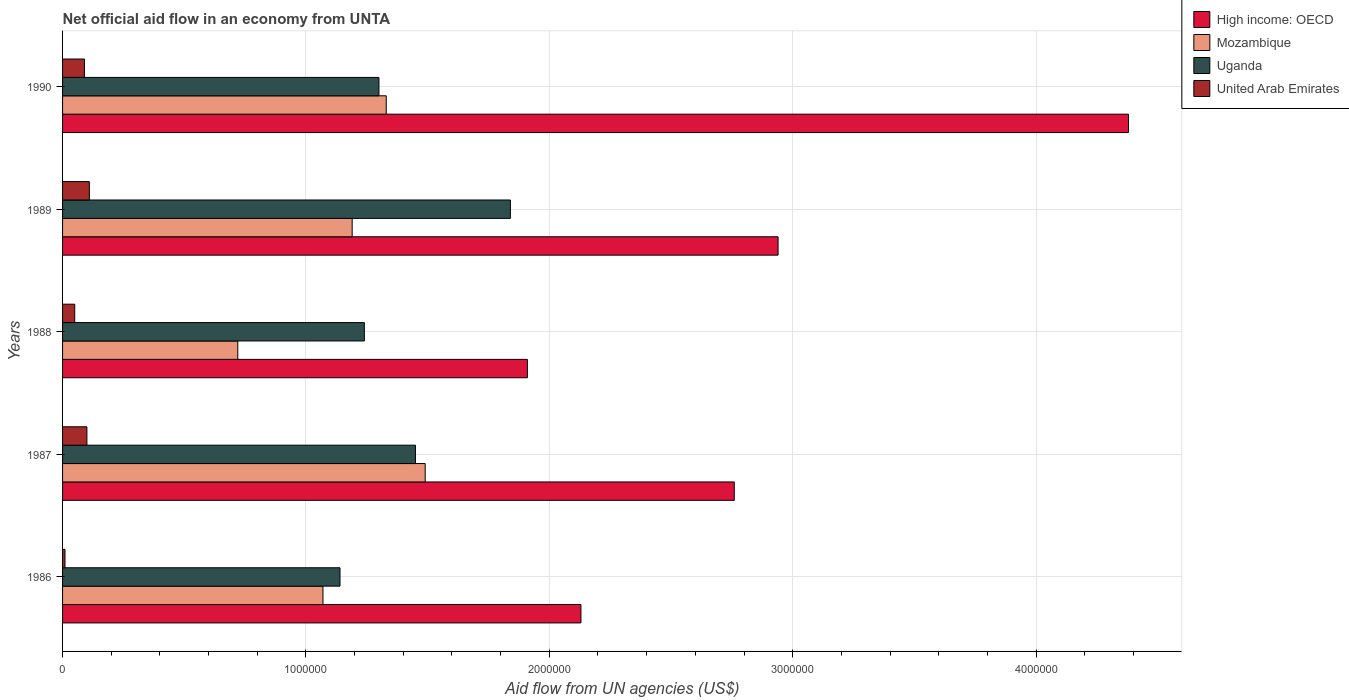Are the number of bars per tick equal to the number of legend labels?
Your answer should be compact. Yes. In how many cases, is the number of bars for a given year not equal to the number of legend labels?
Your answer should be very brief. 0. What is the net official aid flow in United Arab Emirates in 1989?
Offer a terse response. 1.10e+05. Across all years, what is the maximum net official aid flow in United Arab Emirates?
Your answer should be very brief. 1.10e+05. Across all years, what is the minimum net official aid flow in High income: OECD?
Provide a short and direct response. 1.91e+06. In which year was the net official aid flow in High income: OECD minimum?
Your response must be concise. 1988. What is the difference between the net official aid flow in United Arab Emirates in 1989 and the net official aid flow in Uganda in 1986?
Provide a succinct answer. -1.03e+06. What is the average net official aid flow in Uganda per year?
Ensure brevity in your answer.  1.39e+06. In the year 1989, what is the difference between the net official aid flow in Mozambique and net official aid flow in United Arab Emirates?
Keep it short and to the point. 1.08e+06. What is the ratio of the net official aid flow in High income: OECD in 1987 to that in 1989?
Keep it short and to the point. 0.94. Is the net official aid flow in United Arab Emirates in 1987 less than that in 1989?
Provide a succinct answer. Yes. Is the difference between the net official aid flow in Mozambique in 1986 and 1988 greater than the difference between the net official aid flow in United Arab Emirates in 1986 and 1988?
Offer a very short reply. Yes. In how many years, is the net official aid flow in High income: OECD greater than the average net official aid flow in High income: OECD taken over all years?
Keep it short and to the point. 2. What does the 4th bar from the top in 1989 represents?
Provide a succinct answer. High income: OECD. What does the 4th bar from the bottom in 1988 represents?
Provide a succinct answer. United Arab Emirates. How many bars are there?
Ensure brevity in your answer.  20. Are all the bars in the graph horizontal?
Offer a terse response. Yes. What is the difference between two consecutive major ticks on the X-axis?
Provide a short and direct response. 1.00e+06. Does the graph contain any zero values?
Make the answer very short. No. Does the graph contain grids?
Provide a succinct answer. Yes. What is the title of the graph?
Make the answer very short. Net official aid flow in an economy from UNTA. Does "Aruba" appear as one of the legend labels in the graph?
Ensure brevity in your answer.  No. What is the label or title of the X-axis?
Your answer should be compact. Aid flow from UN agencies (US$). What is the label or title of the Y-axis?
Keep it short and to the point. Years. What is the Aid flow from UN agencies (US$) in High income: OECD in 1986?
Your answer should be compact. 2.13e+06. What is the Aid flow from UN agencies (US$) of Mozambique in 1986?
Your answer should be compact. 1.07e+06. What is the Aid flow from UN agencies (US$) of Uganda in 1986?
Provide a short and direct response. 1.14e+06. What is the Aid flow from UN agencies (US$) in United Arab Emirates in 1986?
Give a very brief answer. 10000. What is the Aid flow from UN agencies (US$) in High income: OECD in 1987?
Offer a terse response. 2.76e+06. What is the Aid flow from UN agencies (US$) in Mozambique in 1987?
Keep it short and to the point. 1.49e+06. What is the Aid flow from UN agencies (US$) of Uganda in 1987?
Provide a short and direct response. 1.45e+06. What is the Aid flow from UN agencies (US$) of High income: OECD in 1988?
Offer a very short reply. 1.91e+06. What is the Aid flow from UN agencies (US$) in Mozambique in 1988?
Provide a succinct answer. 7.20e+05. What is the Aid flow from UN agencies (US$) in Uganda in 1988?
Give a very brief answer. 1.24e+06. What is the Aid flow from UN agencies (US$) of High income: OECD in 1989?
Provide a succinct answer. 2.94e+06. What is the Aid flow from UN agencies (US$) of Mozambique in 1989?
Make the answer very short. 1.19e+06. What is the Aid flow from UN agencies (US$) of Uganda in 1989?
Ensure brevity in your answer.  1.84e+06. What is the Aid flow from UN agencies (US$) in United Arab Emirates in 1989?
Your answer should be very brief. 1.10e+05. What is the Aid flow from UN agencies (US$) of High income: OECD in 1990?
Ensure brevity in your answer.  4.38e+06. What is the Aid flow from UN agencies (US$) of Mozambique in 1990?
Give a very brief answer. 1.33e+06. What is the Aid flow from UN agencies (US$) in Uganda in 1990?
Your answer should be compact. 1.30e+06. What is the Aid flow from UN agencies (US$) of United Arab Emirates in 1990?
Provide a succinct answer. 9.00e+04. Across all years, what is the maximum Aid flow from UN agencies (US$) in High income: OECD?
Offer a terse response. 4.38e+06. Across all years, what is the maximum Aid flow from UN agencies (US$) of Mozambique?
Your answer should be compact. 1.49e+06. Across all years, what is the maximum Aid flow from UN agencies (US$) in Uganda?
Offer a very short reply. 1.84e+06. Across all years, what is the maximum Aid flow from UN agencies (US$) of United Arab Emirates?
Your response must be concise. 1.10e+05. Across all years, what is the minimum Aid flow from UN agencies (US$) of High income: OECD?
Provide a short and direct response. 1.91e+06. Across all years, what is the minimum Aid flow from UN agencies (US$) of Mozambique?
Provide a succinct answer. 7.20e+05. Across all years, what is the minimum Aid flow from UN agencies (US$) of Uganda?
Ensure brevity in your answer.  1.14e+06. What is the total Aid flow from UN agencies (US$) in High income: OECD in the graph?
Offer a terse response. 1.41e+07. What is the total Aid flow from UN agencies (US$) of Mozambique in the graph?
Ensure brevity in your answer.  5.80e+06. What is the total Aid flow from UN agencies (US$) in Uganda in the graph?
Keep it short and to the point. 6.97e+06. What is the total Aid flow from UN agencies (US$) of United Arab Emirates in the graph?
Ensure brevity in your answer.  3.60e+05. What is the difference between the Aid flow from UN agencies (US$) in High income: OECD in 1986 and that in 1987?
Give a very brief answer. -6.30e+05. What is the difference between the Aid flow from UN agencies (US$) of Mozambique in 1986 and that in 1987?
Make the answer very short. -4.20e+05. What is the difference between the Aid flow from UN agencies (US$) in Uganda in 1986 and that in 1987?
Offer a terse response. -3.10e+05. What is the difference between the Aid flow from UN agencies (US$) of High income: OECD in 1986 and that in 1988?
Make the answer very short. 2.20e+05. What is the difference between the Aid flow from UN agencies (US$) of Mozambique in 1986 and that in 1988?
Your answer should be compact. 3.50e+05. What is the difference between the Aid flow from UN agencies (US$) in United Arab Emirates in 1986 and that in 1988?
Keep it short and to the point. -4.00e+04. What is the difference between the Aid flow from UN agencies (US$) in High income: OECD in 1986 and that in 1989?
Your response must be concise. -8.10e+05. What is the difference between the Aid flow from UN agencies (US$) in Mozambique in 1986 and that in 1989?
Your response must be concise. -1.20e+05. What is the difference between the Aid flow from UN agencies (US$) in Uganda in 1986 and that in 1989?
Your response must be concise. -7.00e+05. What is the difference between the Aid flow from UN agencies (US$) in High income: OECD in 1986 and that in 1990?
Give a very brief answer. -2.25e+06. What is the difference between the Aid flow from UN agencies (US$) in Mozambique in 1986 and that in 1990?
Provide a succinct answer. -2.60e+05. What is the difference between the Aid flow from UN agencies (US$) in United Arab Emirates in 1986 and that in 1990?
Your answer should be compact. -8.00e+04. What is the difference between the Aid flow from UN agencies (US$) in High income: OECD in 1987 and that in 1988?
Your response must be concise. 8.50e+05. What is the difference between the Aid flow from UN agencies (US$) in Mozambique in 1987 and that in 1988?
Provide a succinct answer. 7.70e+05. What is the difference between the Aid flow from UN agencies (US$) of Uganda in 1987 and that in 1988?
Provide a succinct answer. 2.10e+05. What is the difference between the Aid flow from UN agencies (US$) in United Arab Emirates in 1987 and that in 1988?
Provide a succinct answer. 5.00e+04. What is the difference between the Aid flow from UN agencies (US$) of Uganda in 1987 and that in 1989?
Give a very brief answer. -3.90e+05. What is the difference between the Aid flow from UN agencies (US$) in High income: OECD in 1987 and that in 1990?
Keep it short and to the point. -1.62e+06. What is the difference between the Aid flow from UN agencies (US$) in Mozambique in 1987 and that in 1990?
Your answer should be compact. 1.60e+05. What is the difference between the Aid flow from UN agencies (US$) in High income: OECD in 1988 and that in 1989?
Your response must be concise. -1.03e+06. What is the difference between the Aid flow from UN agencies (US$) of Mozambique in 1988 and that in 1989?
Offer a terse response. -4.70e+05. What is the difference between the Aid flow from UN agencies (US$) in Uganda in 1988 and that in 1989?
Your response must be concise. -6.00e+05. What is the difference between the Aid flow from UN agencies (US$) of United Arab Emirates in 1988 and that in 1989?
Ensure brevity in your answer.  -6.00e+04. What is the difference between the Aid flow from UN agencies (US$) of High income: OECD in 1988 and that in 1990?
Offer a terse response. -2.47e+06. What is the difference between the Aid flow from UN agencies (US$) in Mozambique in 1988 and that in 1990?
Your answer should be very brief. -6.10e+05. What is the difference between the Aid flow from UN agencies (US$) of Uganda in 1988 and that in 1990?
Provide a succinct answer. -6.00e+04. What is the difference between the Aid flow from UN agencies (US$) in United Arab Emirates in 1988 and that in 1990?
Your answer should be very brief. -4.00e+04. What is the difference between the Aid flow from UN agencies (US$) of High income: OECD in 1989 and that in 1990?
Offer a very short reply. -1.44e+06. What is the difference between the Aid flow from UN agencies (US$) in Mozambique in 1989 and that in 1990?
Give a very brief answer. -1.40e+05. What is the difference between the Aid flow from UN agencies (US$) of Uganda in 1989 and that in 1990?
Provide a succinct answer. 5.40e+05. What is the difference between the Aid flow from UN agencies (US$) of United Arab Emirates in 1989 and that in 1990?
Make the answer very short. 2.00e+04. What is the difference between the Aid flow from UN agencies (US$) of High income: OECD in 1986 and the Aid flow from UN agencies (US$) of Mozambique in 1987?
Your answer should be very brief. 6.40e+05. What is the difference between the Aid flow from UN agencies (US$) in High income: OECD in 1986 and the Aid flow from UN agencies (US$) in Uganda in 1987?
Provide a short and direct response. 6.80e+05. What is the difference between the Aid flow from UN agencies (US$) of High income: OECD in 1986 and the Aid flow from UN agencies (US$) of United Arab Emirates in 1987?
Offer a terse response. 2.03e+06. What is the difference between the Aid flow from UN agencies (US$) of Mozambique in 1986 and the Aid flow from UN agencies (US$) of Uganda in 1987?
Ensure brevity in your answer.  -3.80e+05. What is the difference between the Aid flow from UN agencies (US$) in Mozambique in 1986 and the Aid flow from UN agencies (US$) in United Arab Emirates in 1987?
Provide a succinct answer. 9.70e+05. What is the difference between the Aid flow from UN agencies (US$) in Uganda in 1986 and the Aid flow from UN agencies (US$) in United Arab Emirates in 1987?
Make the answer very short. 1.04e+06. What is the difference between the Aid flow from UN agencies (US$) in High income: OECD in 1986 and the Aid flow from UN agencies (US$) in Mozambique in 1988?
Make the answer very short. 1.41e+06. What is the difference between the Aid flow from UN agencies (US$) in High income: OECD in 1986 and the Aid flow from UN agencies (US$) in Uganda in 1988?
Provide a succinct answer. 8.90e+05. What is the difference between the Aid flow from UN agencies (US$) of High income: OECD in 1986 and the Aid flow from UN agencies (US$) of United Arab Emirates in 1988?
Give a very brief answer. 2.08e+06. What is the difference between the Aid flow from UN agencies (US$) in Mozambique in 1986 and the Aid flow from UN agencies (US$) in Uganda in 1988?
Your answer should be compact. -1.70e+05. What is the difference between the Aid flow from UN agencies (US$) of Mozambique in 1986 and the Aid flow from UN agencies (US$) of United Arab Emirates in 1988?
Ensure brevity in your answer.  1.02e+06. What is the difference between the Aid flow from UN agencies (US$) of Uganda in 1986 and the Aid flow from UN agencies (US$) of United Arab Emirates in 1988?
Ensure brevity in your answer.  1.09e+06. What is the difference between the Aid flow from UN agencies (US$) of High income: OECD in 1986 and the Aid flow from UN agencies (US$) of Mozambique in 1989?
Your answer should be compact. 9.40e+05. What is the difference between the Aid flow from UN agencies (US$) of High income: OECD in 1986 and the Aid flow from UN agencies (US$) of United Arab Emirates in 1989?
Offer a very short reply. 2.02e+06. What is the difference between the Aid flow from UN agencies (US$) of Mozambique in 1986 and the Aid flow from UN agencies (US$) of Uganda in 1989?
Offer a terse response. -7.70e+05. What is the difference between the Aid flow from UN agencies (US$) of Mozambique in 1986 and the Aid flow from UN agencies (US$) of United Arab Emirates in 1989?
Keep it short and to the point. 9.60e+05. What is the difference between the Aid flow from UN agencies (US$) of Uganda in 1986 and the Aid flow from UN agencies (US$) of United Arab Emirates in 1989?
Give a very brief answer. 1.03e+06. What is the difference between the Aid flow from UN agencies (US$) in High income: OECD in 1986 and the Aid flow from UN agencies (US$) in Uganda in 1990?
Offer a terse response. 8.30e+05. What is the difference between the Aid flow from UN agencies (US$) in High income: OECD in 1986 and the Aid flow from UN agencies (US$) in United Arab Emirates in 1990?
Make the answer very short. 2.04e+06. What is the difference between the Aid flow from UN agencies (US$) of Mozambique in 1986 and the Aid flow from UN agencies (US$) of Uganda in 1990?
Keep it short and to the point. -2.30e+05. What is the difference between the Aid flow from UN agencies (US$) of Mozambique in 1986 and the Aid flow from UN agencies (US$) of United Arab Emirates in 1990?
Offer a terse response. 9.80e+05. What is the difference between the Aid flow from UN agencies (US$) in Uganda in 1986 and the Aid flow from UN agencies (US$) in United Arab Emirates in 1990?
Provide a short and direct response. 1.05e+06. What is the difference between the Aid flow from UN agencies (US$) in High income: OECD in 1987 and the Aid flow from UN agencies (US$) in Mozambique in 1988?
Give a very brief answer. 2.04e+06. What is the difference between the Aid flow from UN agencies (US$) of High income: OECD in 1987 and the Aid flow from UN agencies (US$) of Uganda in 1988?
Give a very brief answer. 1.52e+06. What is the difference between the Aid flow from UN agencies (US$) of High income: OECD in 1987 and the Aid flow from UN agencies (US$) of United Arab Emirates in 1988?
Provide a succinct answer. 2.71e+06. What is the difference between the Aid flow from UN agencies (US$) in Mozambique in 1987 and the Aid flow from UN agencies (US$) in Uganda in 1988?
Make the answer very short. 2.50e+05. What is the difference between the Aid flow from UN agencies (US$) in Mozambique in 1987 and the Aid flow from UN agencies (US$) in United Arab Emirates in 1988?
Your answer should be compact. 1.44e+06. What is the difference between the Aid flow from UN agencies (US$) in Uganda in 1987 and the Aid flow from UN agencies (US$) in United Arab Emirates in 1988?
Provide a short and direct response. 1.40e+06. What is the difference between the Aid flow from UN agencies (US$) in High income: OECD in 1987 and the Aid flow from UN agencies (US$) in Mozambique in 1989?
Your answer should be compact. 1.57e+06. What is the difference between the Aid flow from UN agencies (US$) of High income: OECD in 1987 and the Aid flow from UN agencies (US$) of Uganda in 1989?
Keep it short and to the point. 9.20e+05. What is the difference between the Aid flow from UN agencies (US$) in High income: OECD in 1987 and the Aid flow from UN agencies (US$) in United Arab Emirates in 1989?
Offer a very short reply. 2.65e+06. What is the difference between the Aid flow from UN agencies (US$) in Mozambique in 1987 and the Aid flow from UN agencies (US$) in Uganda in 1989?
Your response must be concise. -3.50e+05. What is the difference between the Aid flow from UN agencies (US$) of Mozambique in 1987 and the Aid flow from UN agencies (US$) of United Arab Emirates in 1989?
Keep it short and to the point. 1.38e+06. What is the difference between the Aid flow from UN agencies (US$) of Uganda in 1987 and the Aid flow from UN agencies (US$) of United Arab Emirates in 1989?
Your answer should be compact. 1.34e+06. What is the difference between the Aid flow from UN agencies (US$) of High income: OECD in 1987 and the Aid flow from UN agencies (US$) of Mozambique in 1990?
Give a very brief answer. 1.43e+06. What is the difference between the Aid flow from UN agencies (US$) in High income: OECD in 1987 and the Aid flow from UN agencies (US$) in Uganda in 1990?
Provide a short and direct response. 1.46e+06. What is the difference between the Aid flow from UN agencies (US$) in High income: OECD in 1987 and the Aid flow from UN agencies (US$) in United Arab Emirates in 1990?
Make the answer very short. 2.67e+06. What is the difference between the Aid flow from UN agencies (US$) in Mozambique in 1987 and the Aid flow from UN agencies (US$) in Uganda in 1990?
Offer a terse response. 1.90e+05. What is the difference between the Aid flow from UN agencies (US$) of Mozambique in 1987 and the Aid flow from UN agencies (US$) of United Arab Emirates in 1990?
Provide a succinct answer. 1.40e+06. What is the difference between the Aid flow from UN agencies (US$) of Uganda in 1987 and the Aid flow from UN agencies (US$) of United Arab Emirates in 1990?
Your response must be concise. 1.36e+06. What is the difference between the Aid flow from UN agencies (US$) of High income: OECD in 1988 and the Aid flow from UN agencies (US$) of Mozambique in 1989?
Provide a short and direct response. 7.20e+05. What is the difference between the Aid flow from UN agencies (US$) of High income: OECD in 1988 and the Aid flow from UN agencies (US$) of United Arab Emirates in 1989?
Offer a very short reply. 1.80e+06. What is the difference between the Aid flow from UN agencies (US$) of Mozambique in 1988 and the Aid flow from UN agencies (US$) of Uganda in 1989?
Provide a short and direct response. -1.12e+06. What is the difference between the Aid flow from UN agencies (US$) in Uganda in 1988 and the Aid flow from UN agencies (US$) in United Arab Emirates in 1989?
Give a very brief answer. 1.13e+06. What is the difference between the Aid flow from UN agencies (US$) of High income: OECD in 1988 and the Aid flow from UN agencies (US$) of Mozambique in 1990?
Your response must be concise. 5.80e+05. What is the difference between the Aid flow from UN agencies (US$) of High income: OECD in 1988 and the Aid flow from UN agencies (US$) of United Arab Emirates in 1990?
Provide a succinct answer. 1.82e+06. What is the difference between the Aid flow from UN agencies (US$) in Mozambique in 1988 and the Aid flow from UN agencies (US$) in Uganda in 1990?
Give a very brief answer. -5.80e+05. What is the difference between the Aid flow from UN agencies (US$) in Mozambique in 1988 and the Aid flow from UN agencies (US$) in United Arab Emirates in 1990?
Keep it short and to the point. 6.30e+05. What is the difference between the Aid flow from UN agencies (US$) of Uganda in 1988 and the Aid flow from UN agencies (US$) of United Arab Emirates in 1990?
Your response must be concise. 1.15e+06. What is the difference between the Aid flow from UN agencies (US$) in High income: OECD in 1989 and the Aid flow from UN agencies (US$) in Mozambique in 1990?
Your answer should be very brief. 1.61e+06. What is the difference between the Aid flow from UN agencies (US$) in High income: OECD in 1989 and the Aid flow from UN agencies (US$) in Uganda in 1990?
Offer a terse response. 1.64e+06. What is the difference between the Aid flow from UN agencies (US$) of High income: OECD in 1989 and the Aid flow from UN agencies (US$) of United Arab Emirates in 1990?
Offer a terse response. 2.85e+06. What is the difference between the Aid flow from UN agencies (US$) in Mozambique in 1989 and the Aid flow from UN agencies (US$) in Uganda in 1990?
Provide a short and direct response. -1.10e+05. What is the difference between the Aid flow from UN agencies (US$) of Mozambique in 1989 and the Aid flow from UN agencies (US$) of United Arab Emirates in 1990?
Your answer should be compact. 1.10e+06. What is the difference between the Aid flow from UN agencies (US$) in Uganda in 1989 and the Aid flow from UN agencies (US$) in United Arab Emirates in 1990?
Offer a very short reply. 1.75e+06. What is the average Aid flow from UN agencies (US$) of High income: OECD per year?
Your answer should be very brief. 2.82e+06. What is the average Aid flow from UN agencies (US$) in Mozambique per year?
Provide a short and direct response. 1.16e+06. What is the average Aid flow from UN agencies (US$) of Uganda per year?
Make the answer very short. 1.39e+06. What is the average Aid flow from UN agencies (US$) of United Arab Emirates per year?
Ensure brevity in your answer.  7.20e+04. In the year 1986, what is the difference between the Aid flow from UN agencies (US$) in High income: OECD and Aid flow from UN agencies (US$) in Mozambique?
Provide a short and direct response. 1.06e+06. In the year 1986, what is the difference between the Aid flow from UN agencies (US$) in High income: OECD and Aid flow from UN agencies (US$) in Uganda?
Ensure brevity in your answer.  9.90e+05. In the year 1986, what is the difference between the Aid flow from UN agencies (US$) of High income: OECD and Aid flow from UN agencies (US$) of United Arab Emirates?
Your answer should be very brief. 2.12e+06. In the year 1986, what is the difference between the Aid flow from UN agencies (US$) of Mozambique and Aid flow from UN agencies (US$) of United Arab Emirates?
Give a very brief answer. 1.06e+06. In the year 1986, what is the difference between the Aid flow from UN agencies (US$) of Uganda and Aid flow from UN agencies (US$) of United Arab Emirates?
Provide a succinct answer. 1.13e+06. In the year 1987, what is the difference between the Aid flow from UN agencies (US$) of High income: OECD and Aid flow from UN agencies (US$) of Mozambique?
Give a very brief answer. 1.27e+06. In the year 1987, what is the difference between the Aid flow from UN agencies (US$) in High income: OECD and Aid flow from UN agencies (US$) in Uganda?
Make the answer very short. 1.31e+06. In the year 1987, what is the difference between the Aid flow from UN agencies (US$) of High income: OECD and Aid flow from UN agencies (US$) of United Arab Emirates?
Your answer should be very brief. 2.66e+06. In the year 1987, what is the difference between the Aid flow from UN agencies (US$) in Mozambique and Aid flow from UN agencies (US$) in Uganda?
Keep it short and to the point. 4.00e+04. In the year 1987, what is the difference between the Aid flow from UN agencies (US$) in Mozambique and Aid flow from UN agencies (US$) in United Arab Emirates?
Your response must be concise. 1.39e+06. In the year 1987, what is the difference between the Aid flow from UN agencies (US$) of Uganda and Aid flow from UN agencies (US$) of United Arab Emirates?
Make the answer very short. 1.35e+06. In the year 1988, what is the difference between the Aid flow from UN agencies (US$) in High income: OECD and Aid flow from UN agencies (US$) in Mozambique?
Your answer should be compact. 1.19e+06. In the year 1988, what is the difference between the Aid flow from UN agencies (US$) of High income: OECD and Aid flow from UN agencies (US$) of Uganda?
Offer a very short reply. 6.70e+05. In the year 1988, what is the difference between the Aid flow from UN agencies (US$) in High income: OECD and Aid flow from UN agencies (US$) in United Arab Emirates?
Give a very brief answer. 1.86e+06. In the year 1988, what is the difference between the Aid flow from UN agencies (US$) of Mozambique and Aid flow from UN agencies (US$) of Uganda?
Your answer should be compact. -5.20e+05. In the year 1988, what is the difference between the Aid flow from UN agencies (US$) of Mozambique and Aid flow from UN agencies (US$) of United Arab Emirates?
Provide a short and direct response. 6.70e+05. In the year 1988, what is the difference between the Aid flow from UN agencies (US$) in Uganda and Aid flow from UN agencies (US$) in United Arab Emirates?
Offer a terse response. 1.19e+06. In the year 1989, what is the difference between the Aid flow from UN agencies (US$) in High income: OECD and Aid flow from UN agencies (US$) in Mozambique?
Provide a short and direct response. 1.75e+06. In the year 1989, what is the difference between the Aid flow from UN agencies (US$) of High income: OECD and Aid flow from UN agencies (US$) of Uganda?
Give a very brief answer. 1.10e+06. In the year 1989, what is the difference between the Aid flow from UN agencies (US$) in High income: OECD and Aid flow from UN agencies (US$) in United Arab Emirates?
Your answer should be very brief. 2.83e+06. In the year 1989, what is the difference between the Aid flow from UN agencies (US$) of Mozambique and Aid flow from UN agencies (US$) of Uganda?
Your answer should be compact. -6.50e+05. In the year 1989, what is the difference between the Aid flow from UN agencies (US$) in Mozambique and Aid flow from UN agencies (US$) in United Arab Emirates?
Your answer should be very brief. 1.08e+06. In the year 1989, what is the difference between the Aid flow from UN agencies (US$) in Uganda and Aid flow from UN agencies (US$) in United Arab Emirates?
Your response must be concise. 1.73e+06. In the year 1990, what is the difference between the Aid flow from UN agencies (US$) of High income: OECD and Aid flow from UN agencies (US$) of Mozambique?
Provide a short and direct response. 3.05e+06. In the year 1990, what is the difference between the Aid flow from UN agencies (US$) in High income: OECD and Aid flow from UN agencies (US$) in Uganda?
Keep it short and to the point. 3.08e+06. In the year 1990, what is the difference between the Aid flow from UN agencies (US$) of High income: OECD and Aid flow from UN agencies (US$) of United Arab Emirates?
Your response must be concise. 4.29e+06. In the year 1990, what is the difference between the Aid flow from UN agencies (US$) in Mozambique and Aid flow from UN agencies (US$) in Uganda?
Your answer should be very brief. 3.00e+04. In the year 1990, what is the difference between the Aid flow from UN agencies (US$) of Mozambique and Aid flow from UN agencies (US$) of United Arab Emirates?
Ensure brevity in your answer.  1.24e+06. In the year 1990, what is the difference between the Aid flow from UN agencies (US$) of Uganda and Aid flow from UN agencies (US$) of United Arab Emirates?
Offer a very short reply. 1.21e+06. What is the ratio of the Aid flow from UN agencies (US$) of High income: OECD in 1986 to that in 1987?
Your answer should be very brief. 0.77. What is the ratio of the Aid flow from UN agencies (US$) in Mozambique in 1986 to that in 1987?
Ensure brevity in your answer.  0.72. What is the ratio of the Aid flow from UN agencies (US$) in Uganda in 1986 to that in 1987?
Offer a terse response. 0.79. What is the ratio of the Aid flow from UN agencies (US$) of High income: OECD in 1986 to that in 1988?
Make the answer very short. 1.12. What is the ratio of the Aid flow from UN agencies (US$) in Mozambique in 1986 to that in 1988?
Your answer should be very brief. 1.49. What is the ratio of the Aid flow from UN agencies (US$) of Uganda in 1986 to that in 1988?
Your answer should be very brief. 0.92. What is the ratio of the Aid flow from UN agencies (US$) in High income: OECD in 1986 to that in 1989?
Offer a terse response. 0.72. What is the ratio of the Aid flow from UN agencies (US$) of Mozambique in 1986 to that in 1989?
Make the answer very short. 0.9. What is the ratio of the Aid flow from UN agencies (US$) in Uganda in 1986 to that in 1989?
Offer a very short reply. 0.62. What is the ratio of the Aid flow from UN agencies (US$) in United Arab Emirates in 1986 to that in 1989?
Your answer should be compact. 0.09. What is the ratio of the Aid flow from UN agencies (US$) in High income: OECD in 1986 to that in 1990?
Your answer should be compact. 0.49. What is the ratio of the Aid flow from UN agencies (US$) of Mozambique in 1986 to that in 1990?
Keep it short and to the point. 0.8. What is the ratio of the Aid flow from UN agencies (US$) in Uganda in 1986 to that in 1990?
Your answer should be compact. 0.88. What is the ratio of the Aid flow from UN agencies (US$) in United Arab Emirates in 1986 to that in 1990?
Your answer should be compact. 0.11. What is the ratio of the Aid flow from UN agencies (US$) of High income: OECD in 1987 to that in 1988?
Your answer should be very brief. 1.45. What is the ratio of the Aid flow from UN agencies (US$) in Mozambique in 1987 to that in 1988?
Your answer should be very brief. 2.07. What is the ratio of the Aid flow from UN agencies (US$) in Uganda in 1987 to that in 1988?
Keep it short and to the point. 1.17. What is the ratio of the Aid flow from UN agencies (US$) in United Arab Emirates in 1987 to that in 1988?
Your response must be concise. 2. What is the ratio of the Aid flow from UN agencies (US$) in High income: OECD in 1987 to that in 1989?
Give a very brief answer. 0.94. What is the ratio of the Aid flow from UN agencies (US$) of Mozambique in 1987 to that in 1989?
Your response must be concise. 1.25. What is the ratio of the Aid flow from UN agencies (US$) in Uganda in 1987 to that in 1989?
Ensure brevity in your answer.  0.79. What is the ratio of the Aid flow from UN agencies (US$) of United Arab Emirates in 1987 to that in 1989?
Make the answer very short. 0.91. What is the ratio of the Aid flow from UN agencies (US$) of High income: OECD in 1987 to that in 1990?
Provide a succinct answer. 0.63. What is the ratio of the Aid flow from UN agencies (US$) in Mozambique in 1987 to that in 1990?
Give a very brief answer. 1.12. What is the ratio of the Aid flow from UN agencies (US$) in Uganda in 1987 to that in 1990?
Offer a very short reply. 1.12. What is the ratio of the Aid flow from UN agencies (US$) of United Arab Emirates in 1987 to that in 1990?
Provide a succinct answer. 1.11. What is the ratio of the Aid flow from UN agencies (US$) of High income: OECD in 1988 to that in 1989?
Your answer should be compact. 0.65. What is the ratio of the Aid flow from UN agencies (US$) in Mozambique in 1988 to that in 1989?
Provide a succinct answer. 0.6. What is the ratio of the Aid flow from UN agencies (US$) of Uganda in 1988 to that in 1989?
Your answer should be very brief. 0.67. What is the ratio of the Aid flow from UN agencies (US$) of United Arab Emirates in 1988 to that in 1989?
Keep it short and to the point. 0.45. What is the ratio of the Aid flow from UN agencies (US$) in High income: OECD in 1988 to that in 1990?
Provide a short and direct response. 0.44. What is the ratio of the Aid flow from UN agencies (US$) in Mozambique in 1988 to that in 1990?
Provide a short and direct response. 0.54. What is the ratio of the Aid flow from UN agencies (US$) of Uganda in 1988 to that in 1990?
Offer a terse response. 0.95. What is the ratio of the Aid flow from UN agencies (US$) of United Arab Emirates in 1988 to that in 1990?
Give a very brief answer. 0.56. What is the ratio of the Aid flow from UN agencies (US$) in High income: OECD in 1989 to that in 1990?
Offer a very short reply. 0.67. What is the ratio of the Aid flow from UN agencies (US$) of Mozambique in 1989 to that in 1990?
Your answer should be compact. 0.89. What is the ratio of the Aid flow from UN agencies (US$) in Uganda in 1989 to that in 1990?
Provide a short and direct response. 1.42. What is the ratio of the Aid flow from UN agencies (US$) of United Arab Emirates in 1989 to that in 1990?
Offer a terse response. 1.22. What is the difference between the highest and the second highest Aid flow from UN agencies (US$) in High income: OECD?
Keep it short and to the point. 1.44e+06. What is the difference between the highest and the second highest Aid flow from UN agencies (US$) of Mozambique?
Keep it short and to the point. 1.60e+05. What is the difference between the highest and the second highest Aid flow from UN agencies (US$) of United Arab Emirates?
Offer a terse response. 10000. What is the difference between the highest and the lowest Aid flow from UN agencies (US$) of High income: OECD?
Offer a terse response. 2.47e+06. What is the difference between the highest and the lowest Aid flow from UN agencies (US$) of Mozambique?
Your answer should be very brief. 7.70e+05. What is the difference between the highest and the lowest Aid flow from UN agencies (US$) of Uganda?
Offer a very short reply. 7.00e+05. 